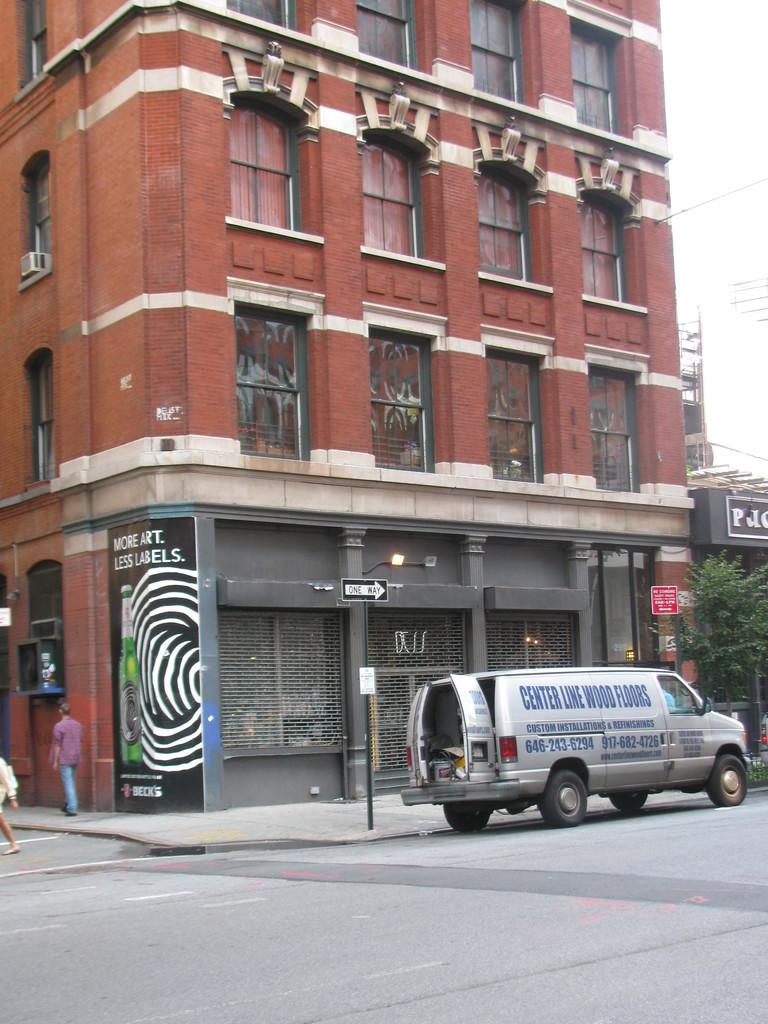<image>
Create a compact narrative representing the image presented. A black and white sign on the corner of a building says "more art, less labels." 